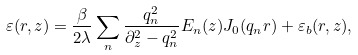Convert formula to latex. <formula><loc_0><loc_0><loc_500><loc_500>\varepsilon ( r , z ) = \frac { \beta } { 2 \lambda } \sum _ { n } \frac { q _ { n } ^ { 2 } } { \partial _ { z } ^ { 2 } - q ^ { 2 } _ { n } } E _ { n } ( z ) J _ { 0 } ( q _ { n } r ) + \varepsilon _ { b } ( r , z ) ,</formula> 